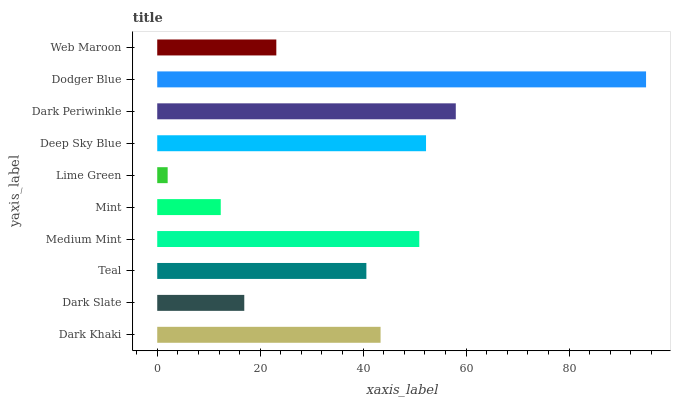Is Lime Green the minimum?
Answer yes or no. Yes. Is Dodger Blue the maximum?
Answer yes or no. Yes. Is Dark Slate the minimum?
Answer yes or no. No. Is Dark Slate the maximum?
Answer yes or no. No. Is Dark Khaki greater than Dark Slate?
Answer yes or no. Yes. Is Dark Slate less than Dark Khaki?
Answer yes or no. Yes. Is Dark Slate greater than Dark Khaki?
Answer yes or no. No. Is Dark Khaki less than Dark Slate?
Answer yes or no. No. Is Dark Khaki the high median?
Answer yes or no. Yes. Is Teal the low median?
Answer yes or no. Yes. Is Web Maroon the high median?
Answer yes or no. No. Is Dodger Blue the low median?
Answer yes or no. No. 